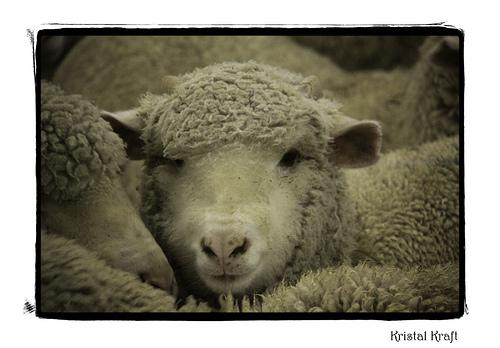What sound will he make?

Choices:
A) meow
B) baa
C) woof
D) quack baa 